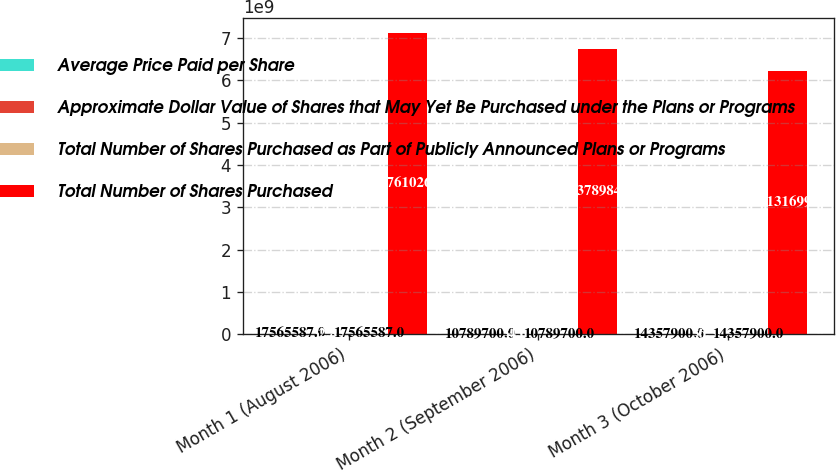Convert chart. <chart><loc_0><loc_0><loc_500><loc_500><stacked_bar_chart><ecel><fcel>Month 1 (August 2006)<fcel>Month 2 (September 2006)<fcel>Month 3 (October 2006)<nl><fcel>Average Price Paid per Share<fcel>1.75656e+07<fcel>1.07897e+07<fcel>1.43579e+07<nl><fcel>Approximate Dollar Value of Shares that May Yet Be Purchased under the Plans or Programs<fcel>32.85<fcel>34.65<fcel>36.39<nl><fcel>Total Number of Shares Purchased as Part of Publicly Announced Plans or Programs<fcel>1.75656e+07<fcel>1.07897e+07<fcel>1.43579e+07<nl><fcel>Total Number of Shares Purchased<fcel>7.12761e+09<fcel>6.75379e+09<fcel>6.23132e+09<nl></chart> 